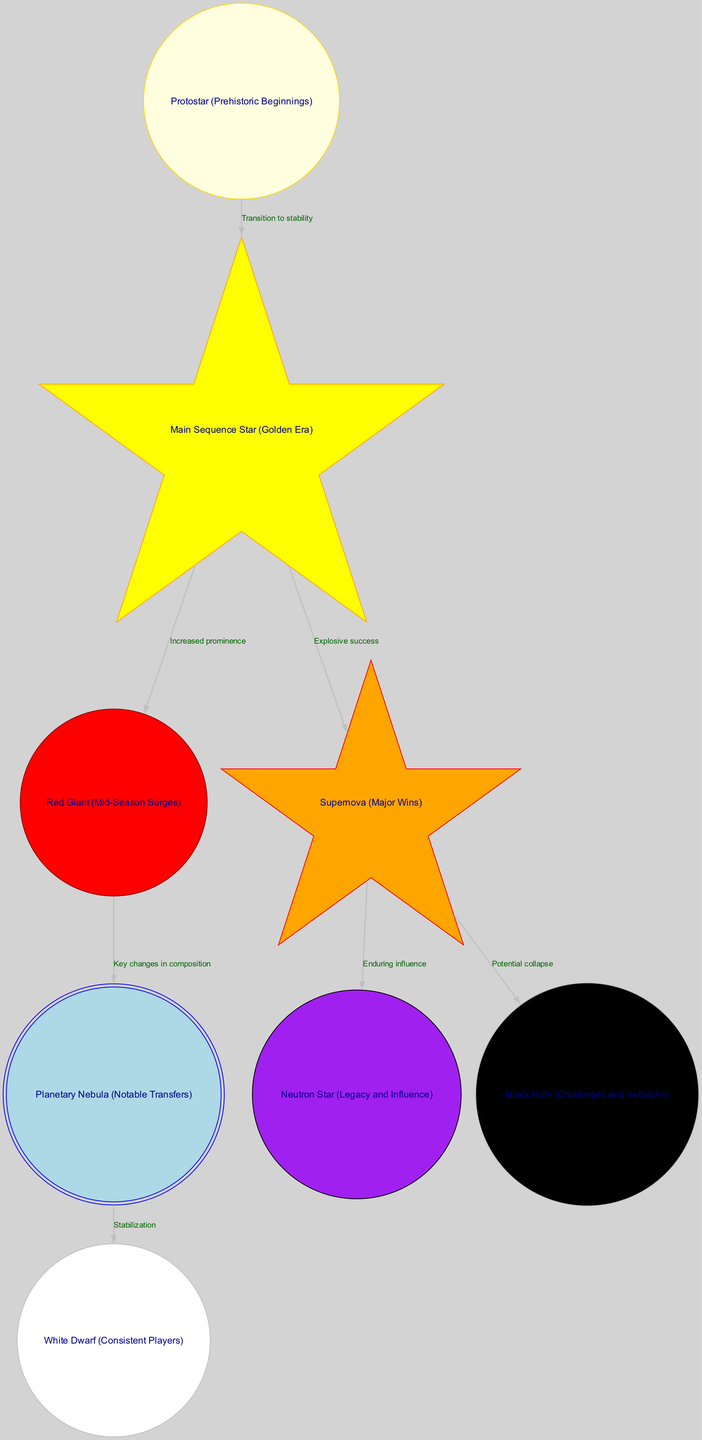What is the first stage of star formation in the diagram? The first node in the diagram is "Protostar (Prehistoric Beginnings)". This node represents the initial gas/dust formation phase in star formation, which is analogous to the early days of Wakefield Trinity.
Answer: Protostar (Prehistoric Beginnings) How many nodes are there in the diagram? By counting each distinct element in the "nodes" section of the data, there are a total of 8 nodes present in the diagram.
Answer: 8 What does the edge from "Main Sequence Star" to "Supernova" signify? This edge labeled "Explosive success" indicates a significant event in the context of the team, where stable phases lead to crucial match victories, linking the success of the golden era to major wins.
Answer: Explosive success What is the final node reached after a "Supernova"? The final node connected by edges to "Supernova" are "Neutron Star" and "Black Hole". This indicates two potential consequences of a supernova event: enduring influence or potential collapse.
Answer: Neutron Star, Black Hole What is the relationship between "Red Giant" and "Planetary Nebula"? The edge between these nodes is labeled "Key changes in composition", showing that significant transformations occur in the team's makeup or performance leading to notable player transfers.
Answer: Key changes in composition What color represents the "Main Sequence Star" in the diagram? The node for "Main Sequence Star" is represented by the color yellow, standing out among other nodes in the diagram.
Answer: Yellow What event leads to the formation of a "White Dwarf"? The transition from "Planetary Nebula" to "White Dwarf" represents a phase of stabilization after mass loss events, pointing to long-standing team members after notable transfers.
Answer: Stabilization How does the diagram connect the notion of "Black Hole" to team challenges? The "Black Hole" node is linked to the "Supernova" through an edge labeled "Potential collapse", indicating that after major wins, the risk of significant challenges to the team's stability is present.
Answer: Potential collapse 